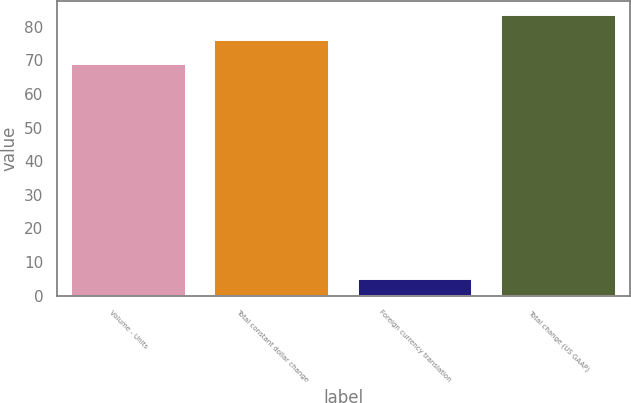<chart> <loc_0><loc_0><loc_500><loc_500><bar_chart><fcel>Volume - Units<fcel>Total constant dollar change<fcel>Foreign currency translation<fcel>Total change (US GAAP)<nl><fcel>68.8<fcel>76.06<fcel>4.9<fcel>83.32<nl></chart> 